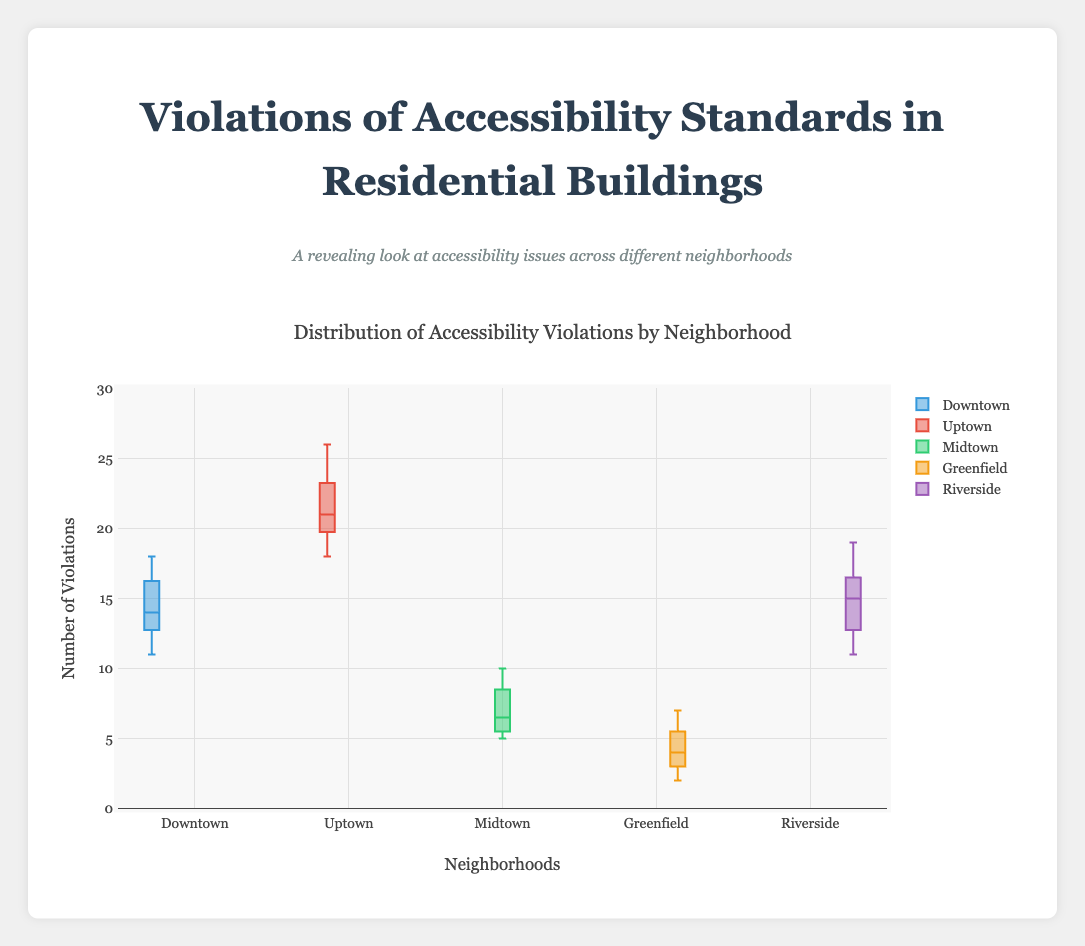What is the title of the figure? From the figure, the title is centrally located at the top and describes the plot. The exact title is "Distribution of Accessibility Violations by Neighborhood".
Answer: Distribution of Accessibility Violations by Neighborhood Which neighborhood has the highest median number of violations? The median is indicated by the line inside each box. By comparing the median lines, Uptown has the highest median number of violations.
Answer: Uptown What is the range of violations in the Greenfield neighborhood? The range is the difference between the maximum and minimum values within the box plot. The maximum is 7 and the minimum is 2. By subtracting, we get 7 - 2 = 5.
Answer: 5 How many neighborhoods have a median number of violations greater than 10? Checking the median lines for each neighborhood, both Downtown and Uptown have medians greater than 10.
Answer: 2 Which neighborhoods have overlapping ranges of violations? By looking at where the boxes and whiskers for each neighborhood overlap, both Downtown and Riverside have overlapping ranges, and Midtown and Greenfield also overlap though less so.
Answer: Downtown and Riverside, Midtown and Greenfield What is the interquartile range (IQR) for the Riverside neighborhood? The IQR is the difference between the upper quartile (Q3) and lower quartile (Q1). For Riverside, approximating from the plot, Q3 is around 16, and Q1 is around 12. Thus, IQR = 16 - 12 = 4.
Answer: 4 Which neighborhood has the smallest overall spread of violations, and what is it? The spread of violations is determined by the range (max - min) in each box plot. Greenfield has the smallest spread with max = 7 and min = 2, giving a spread of 7 - 2 = 5.
Answer: Greenfield, 5 How does the number of violations in Uptown compare to Downtown? Uptown has consistently higher values for violations compared to Downtown. This is observed by comparing the location of the boxes and the medians.
Answer: Uptown has consistently higher values What can be inferred about the variability in violations between Midtown and Uptown? The variability can be observed by comparing the length of the boxes and whiskers. Uptown has a larger box and whiskers, indicating it has higher variability compared to Midtown.
Answer: Uptown has higher variability Which neighborhood contains potential outliers, and how can you tell? Outliers are the points that fall outside the whiskers of the box plot. In this case, there are no clear points situated outside any of the whiskers, suggesting there are no apparent outliers.
Answer: None 